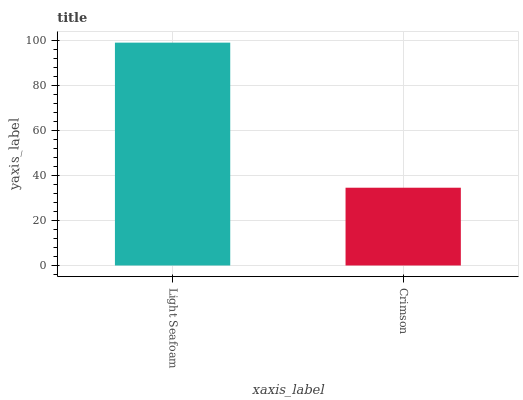Is Crimson the minimum?
Answer yes or no. Yes. Is Light Seafoam the maximum?
Answer yes or no. Yes. Is Crimson the maximum?
Answer yes or no. No. Is Light Seafoam greater than Crimson?
Answer yes or no. Yes. Is Crimson less than Light Seafoam?
Answer yes or no. Yes. Is Crimson greater than Light Seafoam?
Answer yes or no. No. Is Light Seafoam less than Crimson?
Answer yes or no. No. Is Light Seafoam the high median?
Answer yes or no. Yes. Is Crimson the low median?
Answer yes or no. Yes. Is Crimson the high median?
Answer yes or no. No. Is Light Seafoam the low median?
Answer yes or no. No. 